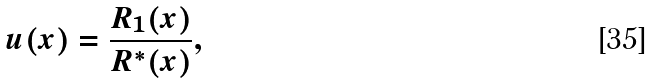Convert formula to latex. <formula><loc_0><loc_0><loc_500><loc_500>u ( x ) = \frac { R _ { 1 } ( x ) } { R ^ { * } ( x ) } ,</formula> 